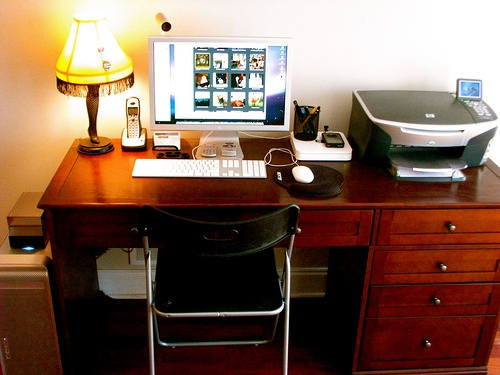Describe the objects in this image and their specific colors. I can see chair in tan, black, gray, maroon, and darkgreen tones, tv in tan, white, teal, black, and gray tones, keyboard in tan, white, lightgray, and darkgray tones, cup in tan, black, maroon, olive, and gray tones, and cell phone in tan, ivory, olive, and maroon tones in this image. 